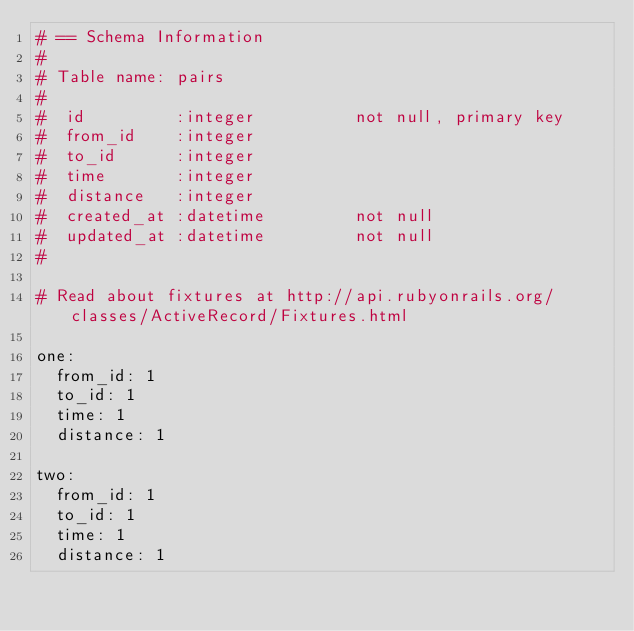<code> <loc_0><loc_0><loc_500><loc_500><_YAML_># == Schema Information
#
# Table name: pairs
#
#  id         :integer          not null, primary key
#  from_id    :integer
#  to_id      :integer
#  time       :integer
#  distance   :integer
#  created_at :datetime         not null
#  updated_at :datetime         not null
#

# Read about fixtures at http://api.rubyonrails.org/classes/ActiveRecord/Fixtures.html

one:
  from_id: 1
  to_id: 1
  time: 1
  distance: 1

two:
  from_id: 1
  to_id: 1
  time: 1
  distance: 1
</code> 